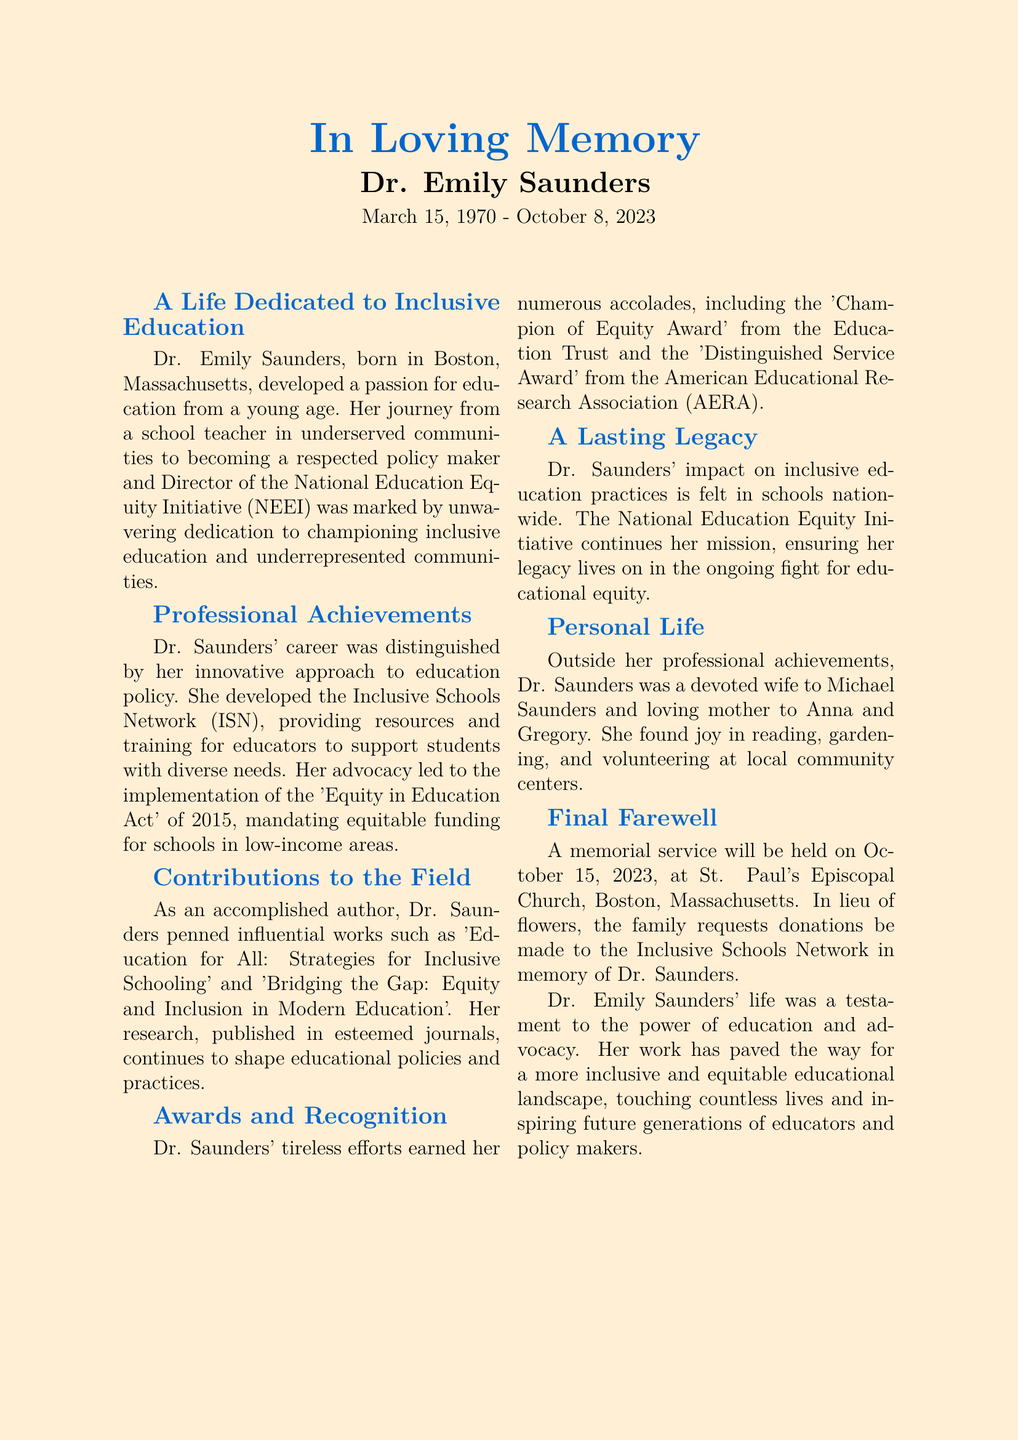What was Dr. Emily Saunders' role at the NEEI? Dr. Emily Saunders served as the Director of the National Education Equity Initiative, which is mentioned in her professional achievements.
Answer: Director When was Dr. Emily Saunders born? The document states that Dr. Emily Saunders was born on March 15, 1970.
Answer: March 15, 1970 What award did Dr. Saunders receive from the Education Trust? The document mentions that she received the 'Champion of Equity Award' for her contributions to educational equity.
Answer: Champion of Equity Award What was the name of Dr. Saunders' influential book on inclusive schooling? One of her noted works, as listed in the contributions section, is 'Education for All: Strategies for Inclusive Schooling.'
Answer: Education for All: Strategies for Inclusive Schooling How many children did Dr. Saunders have? The document mentions that she was a loving mother to two children, Anna and Gregory.
Answer: Two What initiative did Dr. Saunders develop to support diverse learners? The document states that she developed the Inclusive Schools Network to provide resources for educators.
Answer: Inclusive Schools Network What date is the memorial service scheduled for? The obituary specifies that the memorial service will be held on October 15, 2023.
Answer: October 15, 2023 In which city was Dr. Emily Saunders born? According to the document, Dr. Emily Saunders was born in Boston, Massachusetts.
Answer: Boston What was Dr. Saunders' primary advocacy focus? The obituary highlights her commitment to championing inclusive education and underrepresented communities.
Answer: Inclusive education 